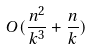<formula> <loc_0><loc_0><loc_500><loc_500>O ( \frac { n ^ { 2 } } { k ^ { 3 } } + \frac { n } { k } )</formula> 